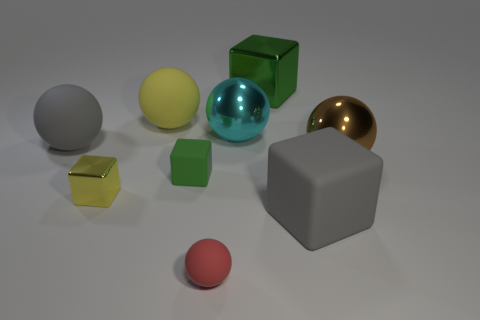Subtract all large gray cubes. How many cubes are left? 3 Subtract all balls. How many objects are left? 4 Subtract all cyan spheres. How many spheres are left? 4 Subtract 3 blocks. How many blocks are left? 1 Add 7 small green objects. How many small green objects exist? 8 Subtract 0 purple cubes. How many objects are left? 9 Subtract all red balls. Subtract all purple cylinders. How many balls are left? 4 Subtract all cyan blocks. How many brown spheres are left? 1 Subtract all big shiny balls. Subtract all large yellow rubber objects. How many objects are left? 6 Add 5 big brown balls. How many big brown balls are left? 6 